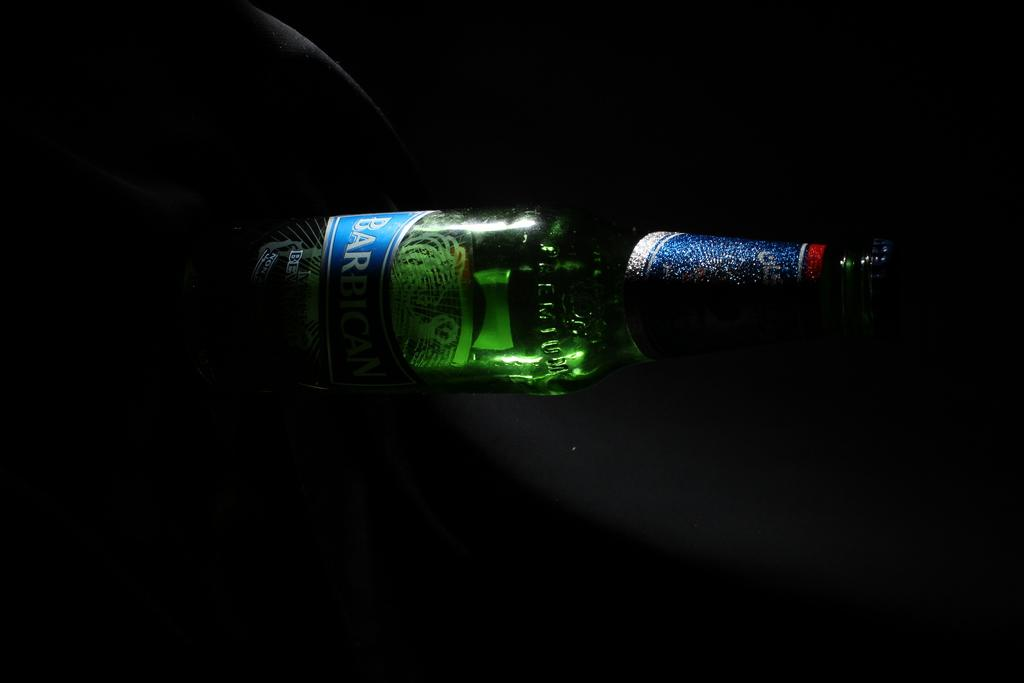<image>
Describe the image concisely. A bottle of beer starting with "BAR" sits in a nearly dark room. 